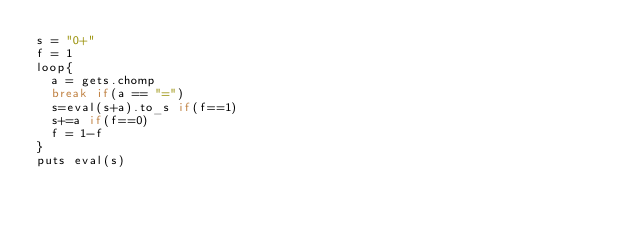<code> <loc_0><loc_0><loc_500><loc_500><_Ruby_>s = "0+"
f = 1
loop{
	a = gets.chomp
	break if(a == "=")
	s=eval(s+a).to_s if(f==1)
	s+=a if(f==0)
	f = 1-f
}
puts eval(s)
	</code> 